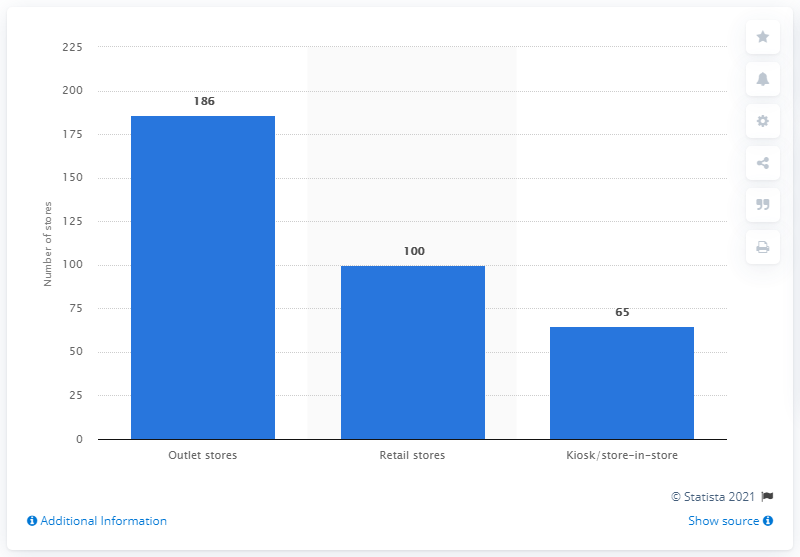Mention a couple of crucial points in this snapshot. In 2020, Crocs had a total of 186 outlet stores. In 2020, Crocs had a total of 65 kiosks and store-in-store locations. 